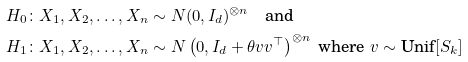Convert formula to latex. <formula><loc_0><loc_0><loc_500><loc_500>& H _ { 0 } \colon X _ { 1 } , X _ { 2 } , \dots , X _ { n } \sim N ( 0 , I _ { d } ) ^ { \otimes n } \quad \text {and} \\ & H _ { 1 } \colon X _ { 1 } , X _ { 2 } , \dots , X _ { n } \sim N \left ( 0 , I _ { d } + \theta v v ^ { \top } \right ) ^ { \otimes n } \text { where } v \sim \text {Unif} [ S _ { k } ]</formula> 